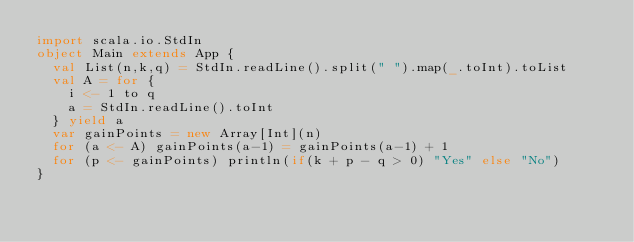Convert code to text. <code><loc_0><loc_0><loc_500><loc_500><_Scala_>import scala.io.StdIn
object Main extends App {
  val List(n,k,q) = StdIn.readLine().split(" ").map(_.toInt).toList
  val A = for {
    i <- 1 to q
    a = StdIn.readLine().toInt
  } yield a
  var gainPoints = new Array[Int](n)
  for (a <- A) gainPoints(a-1) = gainPoints(a-1) + 1
  for (p <- gainPoints) println(if(k + p - q > 0) "Yes" else "No")
}
</code> 